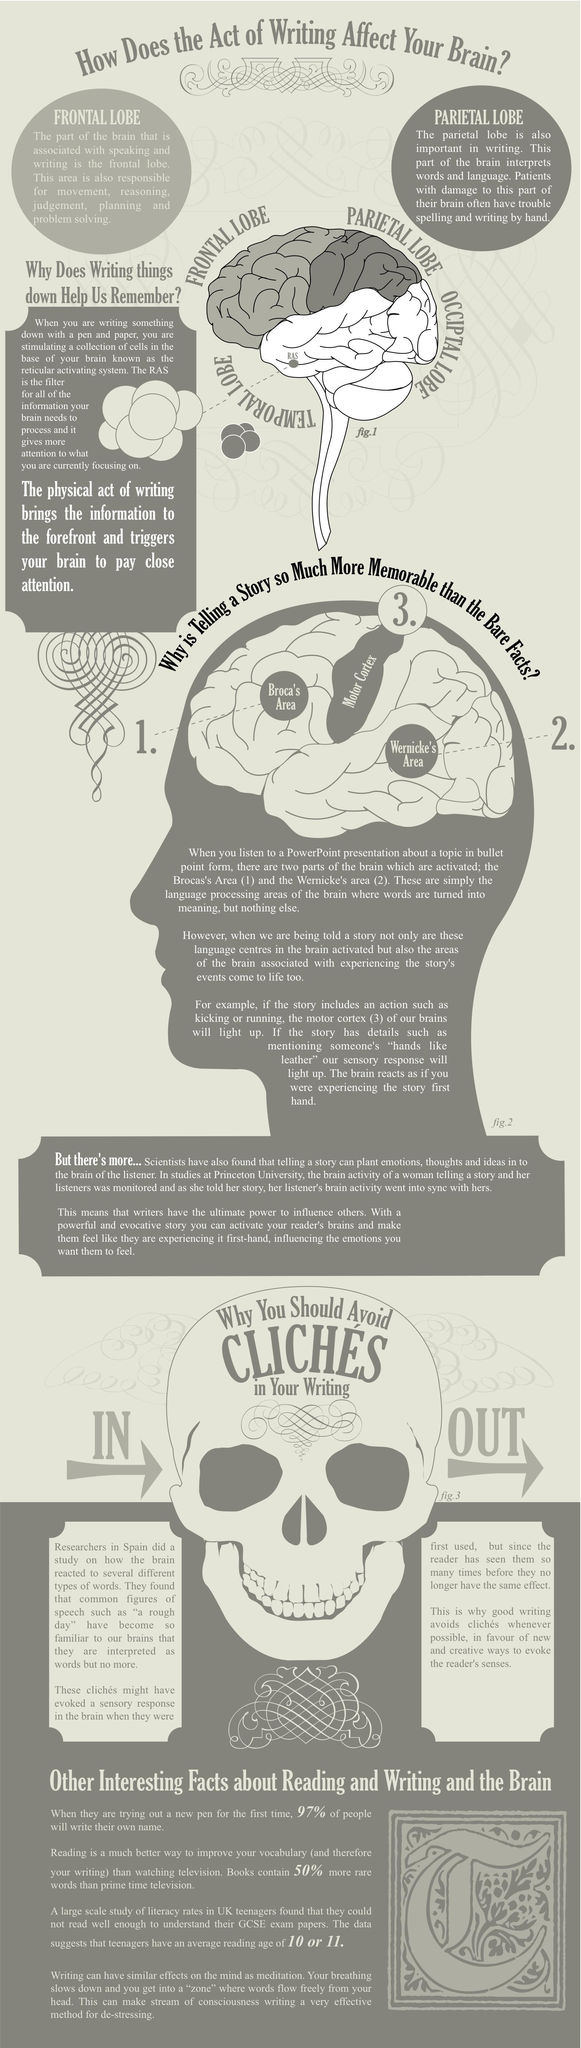how many different types of lobes are mentioned?
Answer the question with a short phrase. 4 what is mentioned on the forehead of the skull why you should avoid cliches in your writing which lobe is associated with problem solving frontal lobe in which colour is the occiptal lobe shown, grey or white? white RAS is found in which lobe temporal lobe 